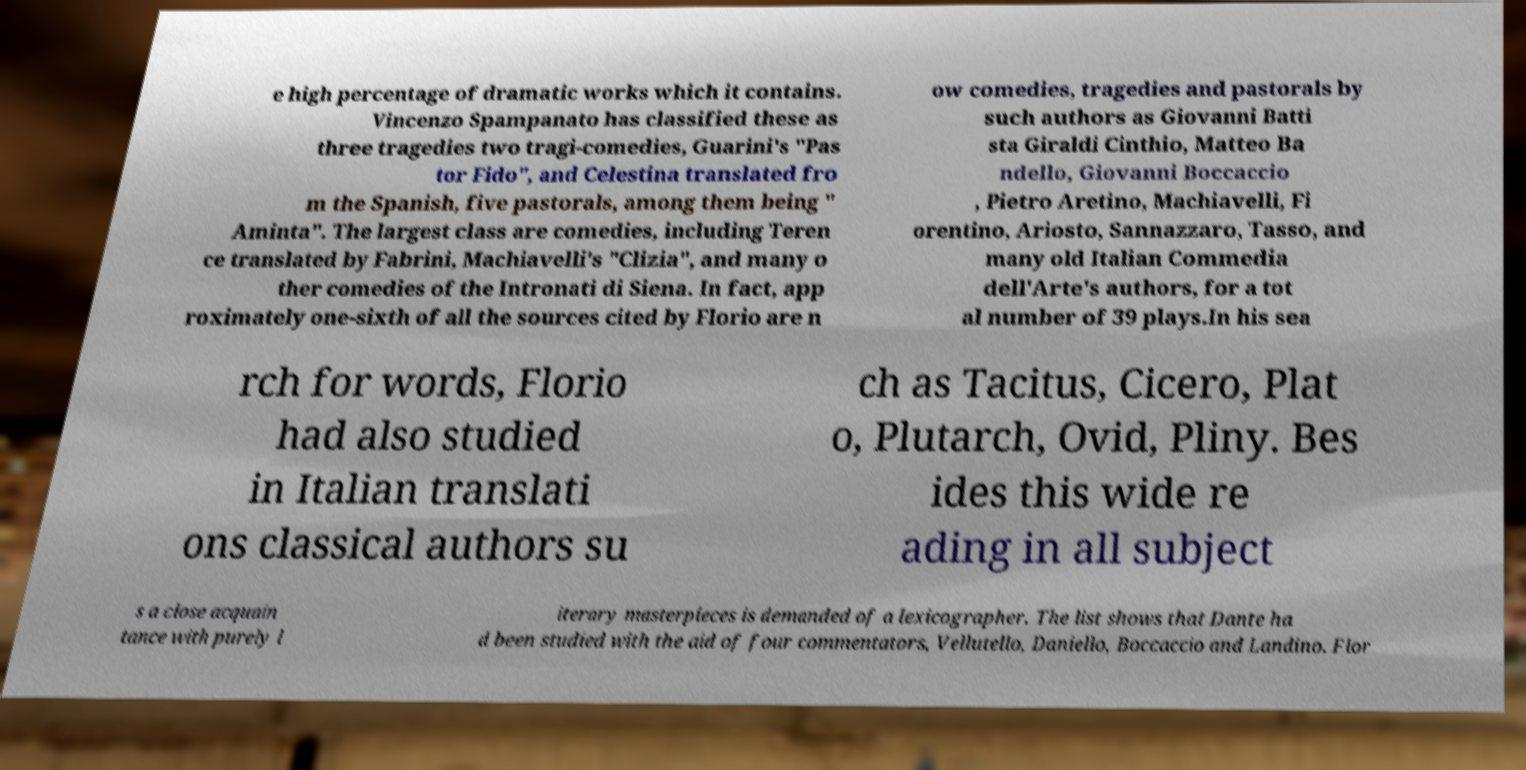Can you accurately transcribe the text from the provided image for me? e high percentage of dramatic works which it contains. Vincenzo Spampanato has classified these as three tragedies two tragi-comedies, Guarini's "Pas tor Fido", and Celestina translated fro m the Spanish, five pastorals, among them being " Aminta". The largest class are comedies, including Teren ce translated by Fabrini, Machiavelli's "Clizia", and many o ther comedies of the Intronati di Siena. In fact, app roximately one-sixth of all the sources cited by Florio are n ow comedies, tragedies and pastorals by such authors as Giovanni Batti sta Giraldi Cinthio, Matteo Ba ndello, Giovanni Boccaccio , Pietro Aretino, Machiavelli, Fi orentino, Ariosto, Sannazzaro, Tasso, and many old Italian Commedia dell'Arte's authors, for a tot al number of 39 plays.In his sea rch for words, Florio had also studied in Italian translati ons classical authors su ch as Tacitus, Cicero, Plat o, Plutarch, Ovid, Pliny. Bes ides this wide re ading in all subject s a close acquain tance with purely l iterary masterpieces is demanded of a lexicographer. The list shows that Dante ha d been studied with the aid of four commentators, Vellutello, Daniello, Boccaccio and Landino. Flor 